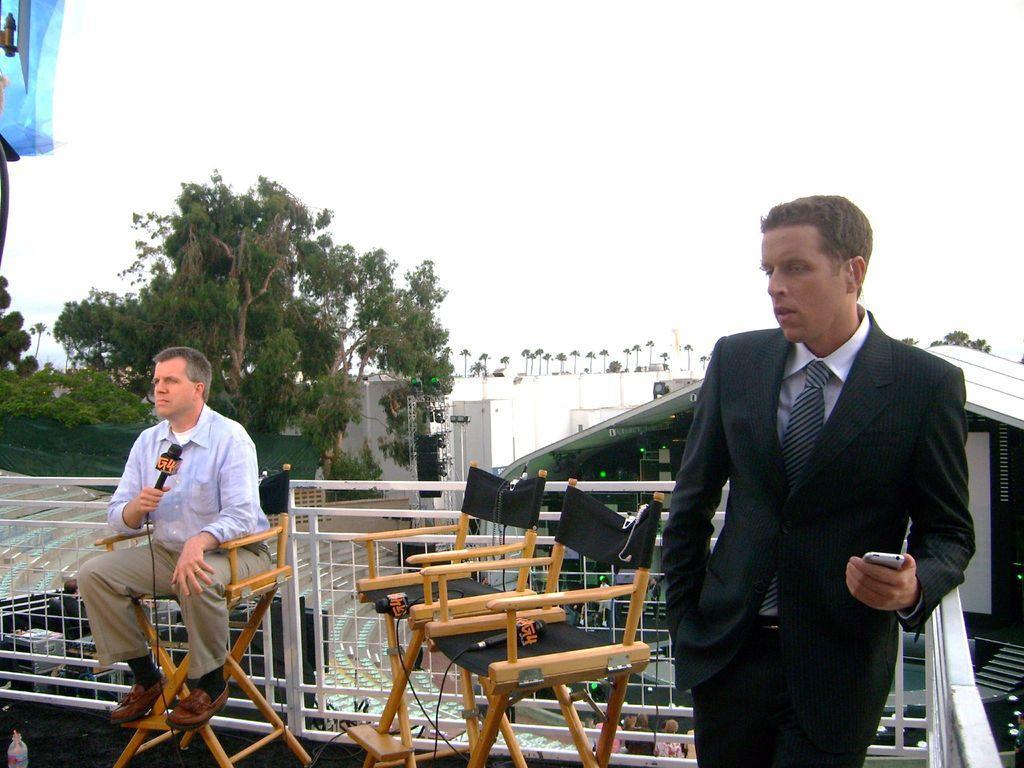Describe this image in one or two sentences. In the image we can see there are two men. A man who is standing another man is sitting and holding a mike in his hand and at the back there are trees and there is a clear sky. 